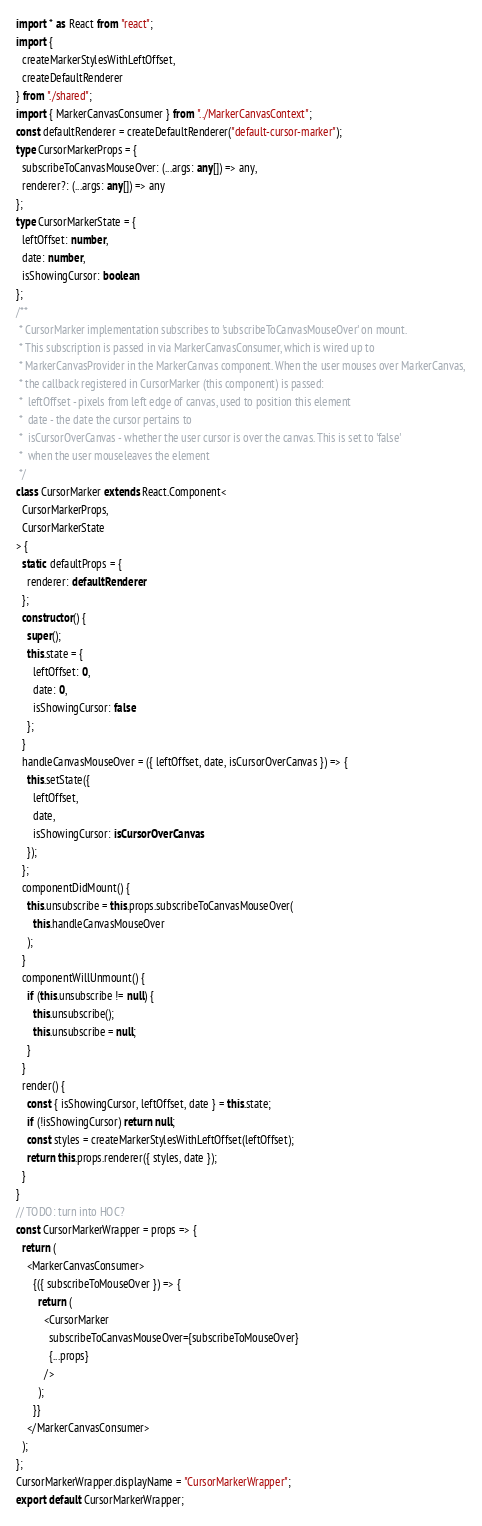Convert code to text. <code><loc_0><loc_0><loc_500><loc_500><_TypeScript_>import * as React from "react";
import {
  createMarkerStylesWithLeftOffset,
  createDefaultRenderer
} from "./shared";
import { MarkerCanvasConsumer } from "../MarkerCanvasContext";
const defaultRenderer = createDefaultRenderer("default-cursor-marker");
type CursorMarkerProps = {
  subscribeToCanvasMouseOver: (...args: any[]) => any,
  renderer?: (...args: any[]) => any
};
type CursorMarkerState = {
  leftOffset: number,
  date: number,
  isShowingCursor: boolean
};
/**
 * CursorMarker implementation subscribes to 'subscribeToCanvasMouseOver' on mount.
 * This subscription is passed in via MarkerCanvasConsumer, which is wired up to
 * MarkerCanvasProvider in the MarkerCanvas component. When the user mouses over MarkerCanvas,
 * the callback registered in CursorMarker (this component) is passed:
 *  leftOffset - pixels from left edge of canvas, used to position this element
 *  date - the date the cursor pertains to
 *  isCursorOverCanvas - whether the user cursor is over the canvas. This is set to 'false'
 *  when the user mouseleaves the element
 */
class CursorMarker extends React.Component<
  CursorMarkerProps,
  CursorMarkerState
> {
  static defaultProps = {
    renderer: defaultRenderer
  };
  constructor() {
    super();
    this.state = {
      leftOffset: 0,
      date: 0,
      isShowingCursor: false
    };
  }
  handleCanvasMouseOver = ({ leftOffset, date, isCursorOverCanvas }) => {
    this.setState({
      leftOffset,
      date,
      isShowingCursor: isCursorOverCanvas
    });
  };
  componentDidMount() {
    this.unsubscribe = this.props.subscribeToCanvasMouseOver(
      this.handleCanvasMouseOver
    );
  }
  componentWillUnmount() {
    if (this.unsubscribe != null) {
      this.unsubscribe();
      this.unsubscribe = null;
    }
  }
  render() {
    const { isShowingCursor, leftOffset, date } = this.state;
    if (!isShowingCursor) return null;
    const styles = createMarkerStylesWithLeftOffset(leftOffset);
    return this.props.renderer({ styles, date });
  }
}
// TODO: turn into HOC?
const CursorMarkerWrapper = props => {
  return (
    <MarkerCanvasConsumer>
      {({ subscribeToMouseOver }) => {
        return (
          <CursorMarker
            subscribeToCanvasMouseOver={subscribeToMouseOver}
            {...props}
          />
        );
      }}
    </MarkerCanvasConsumer>
  );
};
CursorMarkerWrapper.displayName = "CursorMarkerWrapper";
export default CursorMarkerWrapper;
</code> 